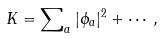<formula> <loc_0><loc_0><loc_500><loc_500>K = \sum \nolimits _ { a } | \phi _ { a } | ^ { 2 } + \cdots ,</formula> 